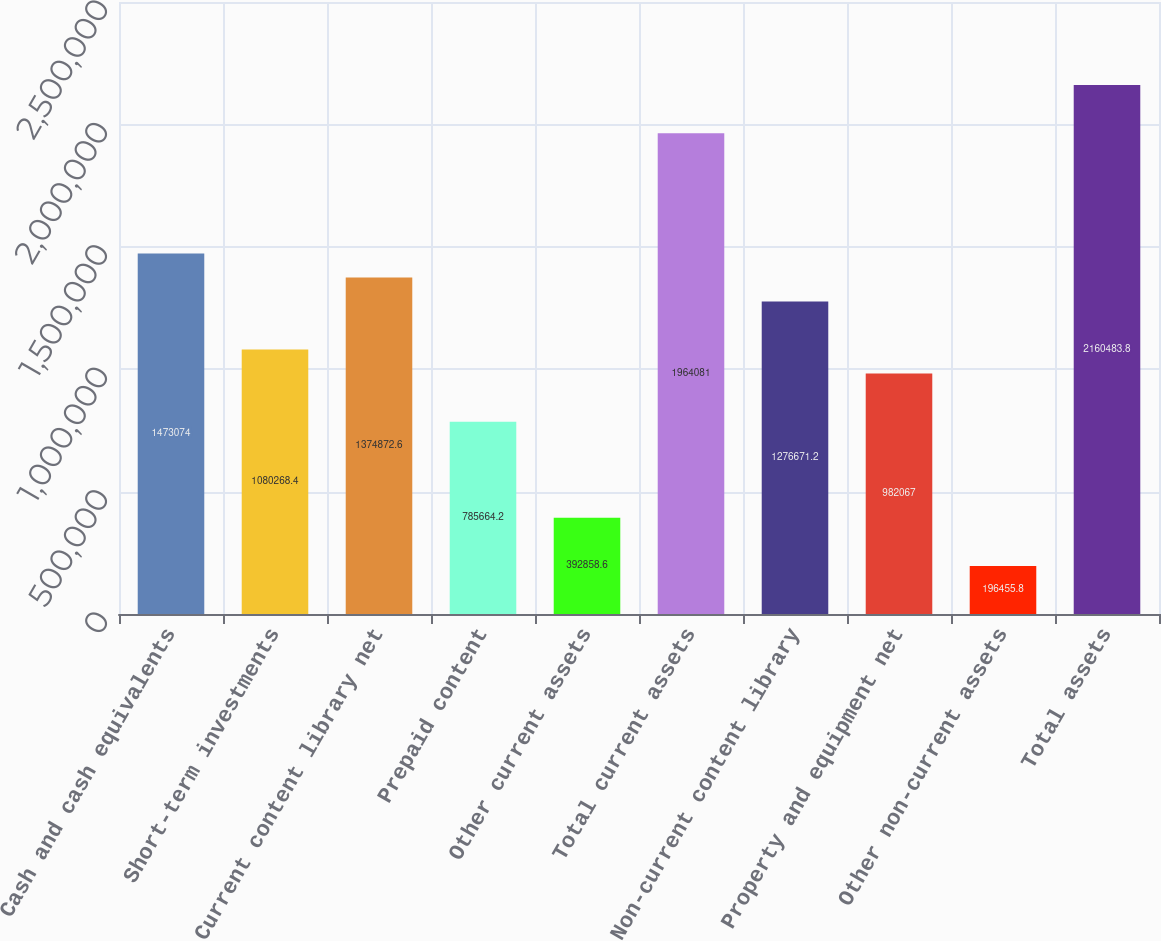<chart> <loc_0><loc_0><loc_500><loc_500><bar_chart><fcel>Cash and cash equivalents<fcel>Short-term investments<fcel>Current content library net<fcel>Prepaid content<fcel>Other current assets<fcel>Total current assets<fcel>Non-current content library<fcel>Property and equipment net<fcel>Other non-current assets<fcel>Total assets<nl><fcel>1.47307e+06<fcel>1.08027e+06<fcel>1.37487e+06<fcel>785664<fcel>392859<fcel>1.96408e+06<fcel>1.27667e+06<fcel>982067<fcel>196456<fcel>2.16048e+06<nl></chart> 